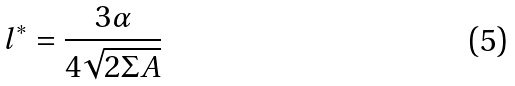<formula> <loc_0><loc_0><loc_500><loc_500>l ^ { * } = \frac { 3 \alpha } { 4 \sqrt { 2 \Sigma A } }</formula> 